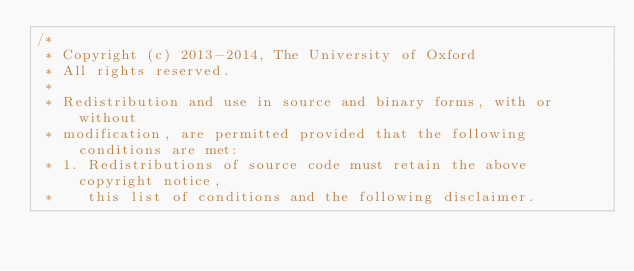Convert code to text. <code><loc_0><loc_0><loc_500><loc_500><_Cuda_>/*
 * Copyright (c) 2013-2014, The University of Oxford
 * All rights reserved.
 *
 * Redistribution and use in source and binary forms, with or without
 * modification, are permitted provided that the following conditions are met:
 * 1. Redistributions of source code must retain the above copyright notice,
 *    this list of conditions and the following disclaimer.</code> 